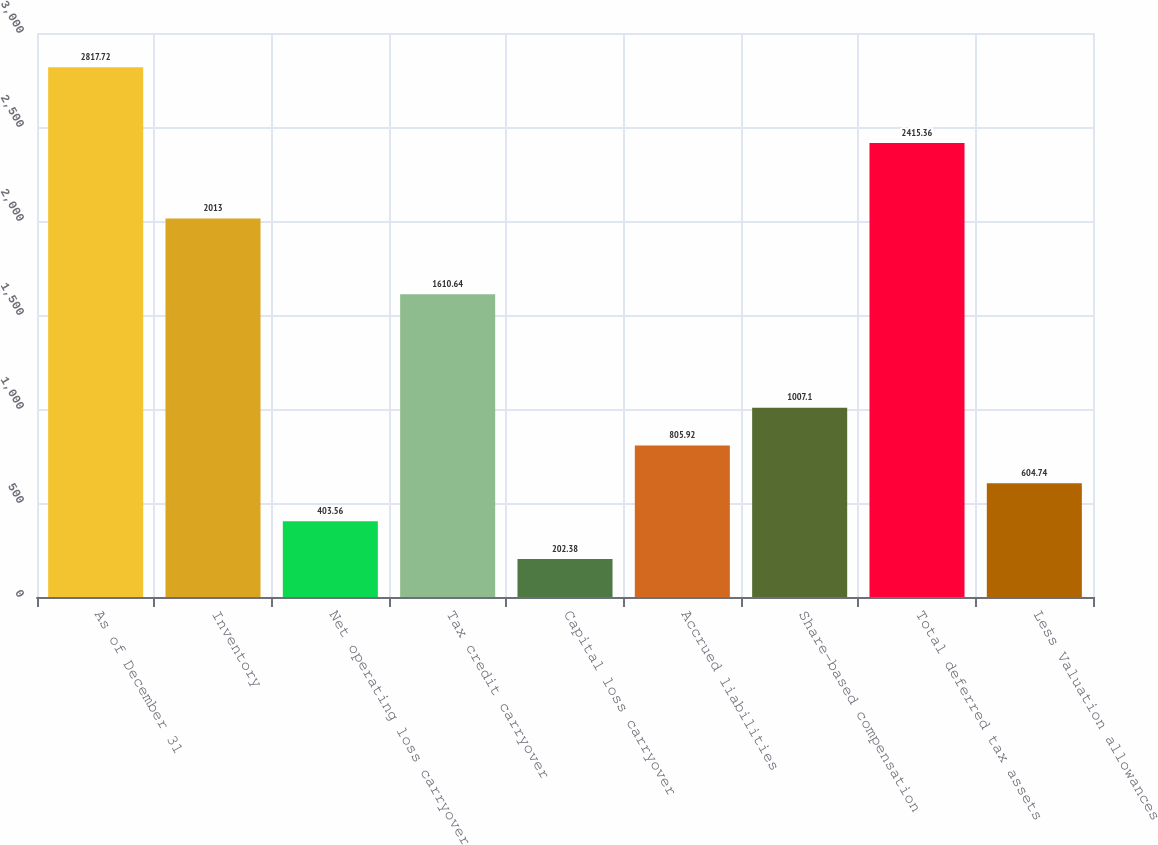Convert chart to OTSL. <chart><loc_0><loc_0><loc_500><loc_500><bar_chart><fcel>As of December 31<fcel>Inventory<fcel>Net operating loss carryover<fcel>Tax credit carryover<fcel>Capital loss carryover<fcel>Accrued liabilities<fcel>Share-based compensation<fcel>Total deferred tax assets<fcel>Less Valuation allowances<nl><fcel>2817.72<fcel>2013<fcel>403.56<fcel>1610.64<fcel>202.38<fcel>805.92<fcel>1007.1<fcel>2415.36<fcel>604.74<nl></chart> 